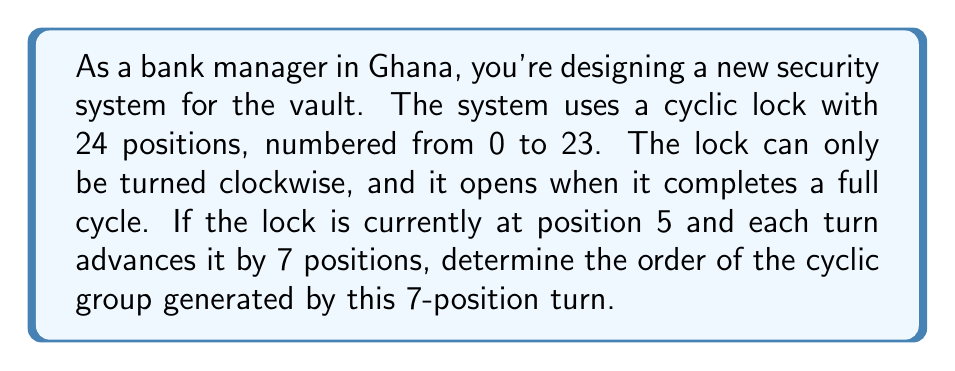Could you help me with this problem? To solve this problem, we need to understand the concept of cyclic groups and how to determine their order. Let's approach this step-by-step:

1) First, we need to recognize that this lock system forms a cyclic group of order 24, as there are 24 distinct positions.

2) The generator of our subgroup is the 7-position turn. Let's call this generator $a$.

3) To find the order of the subgroup generated by $a$, we need to find the smallest positive integer $n$ such that $a^n \equiv e \pmod{24}$, where $e$ is the identity element (in this case, a complete rotation back to the starting position).

4) Mathematically, we're solving the congruence:

   $7n \equiv 0 \pmod{24}$

5) We can solve this by finding the least common multiple (LCM) of 7 and 24:

   $LCM(7,24) = \frac{7 \times 24}{GCD(7,24)} = \frac{168}{1} = 168$

6) Therefore, the smallest $n$ that satisfies the congruence is:

   $n = \frac{168}{7} = 24$

7) This means that after 24 turns of 7 positions each, the lock will complete a full cycle and return to its starting position.

8) We can verify this:
   $24 \times 7 = 168 \equiv 0 \pmod{24}$

Therefore, the order of the cyclic subgroup generated by the 7-position turn is 24.
Answer: The order of the cyclic group generated by the 7-position turn is 24. 